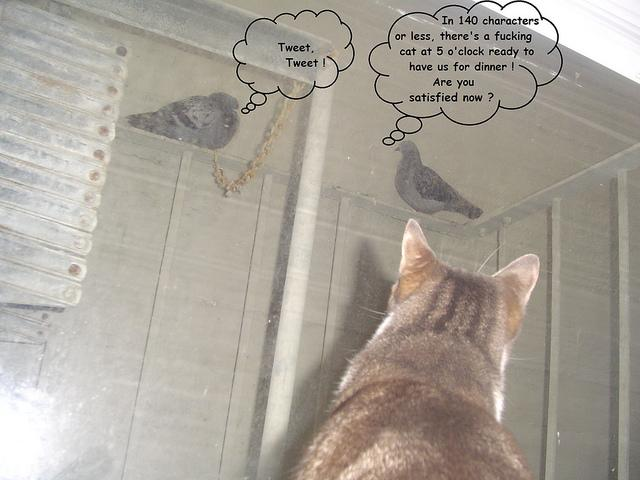The dialogue bubbles are an example of what editing technique? Please explain your reasoning. superimposition. The bubbles are superimposed. 